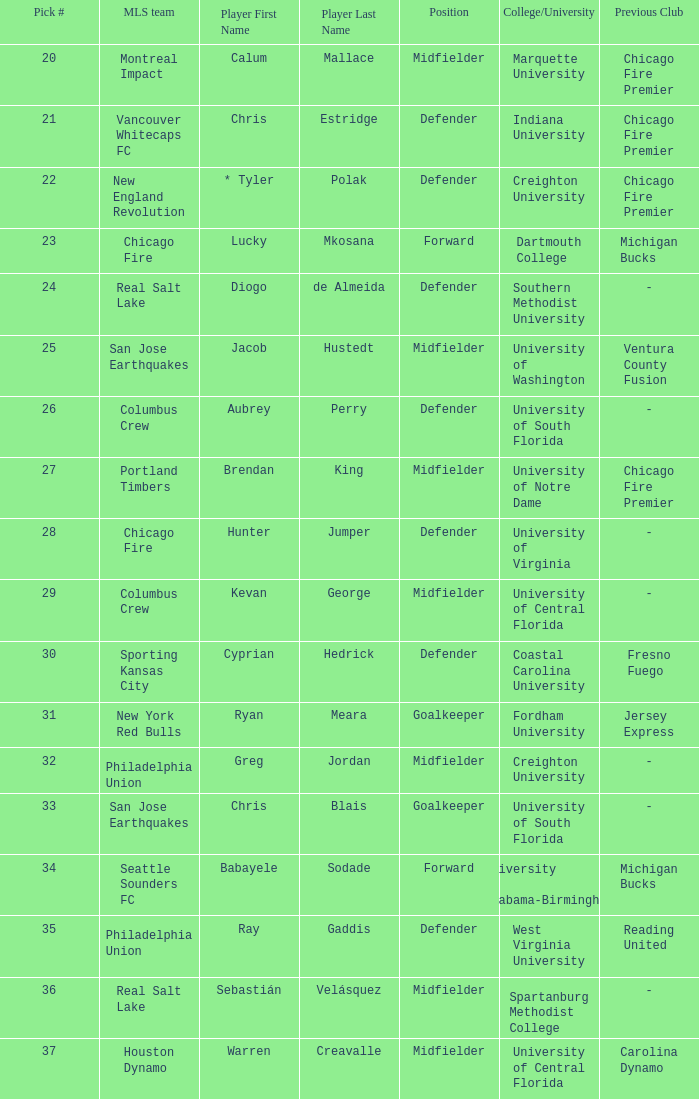At which position did real salt lake pick? 24.0. 